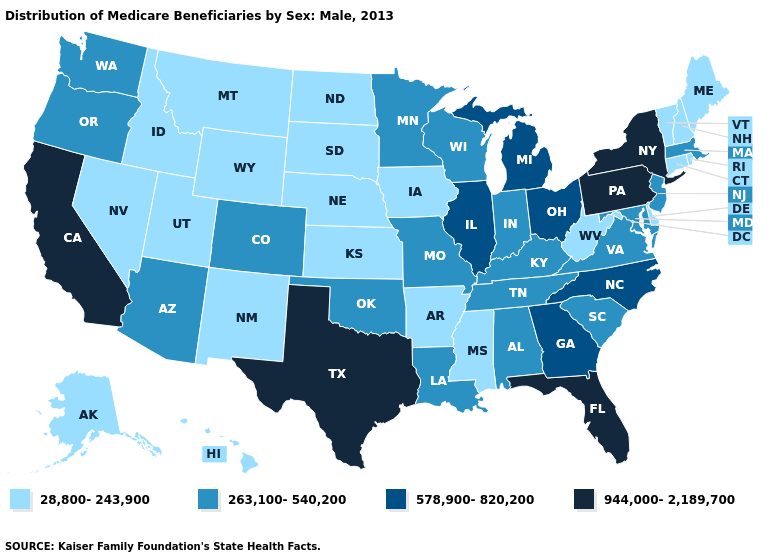What is the highest value in states that border Pennsylvania?
Concise answer only. 944,000-2,189,700. Among the states that border Missouri , which have the highest value?
Keep it brief. Illinois. Does the map have missing data?
Be succinct. No. Which states have the lowest value in the MidWest?
Keep it brief. Iowa, Kansas, Nebraska, North Dakota, South Dakota. What is the lowest value in the USA?
Give a very brief answer. 28,800-243,900. Name the states that have a value in the range 263,100-540,200?
Write a very short answer. Alabama, Arizona, Colorado, Indiana, Kentucky, Louisiana, Maryland, Massachusetts, Minnesota, Missouri, New Jersey, Oklahoma, Oregon, South Carolina, Tennessee, Virginia, Washington, Wisconsin. What is the value of Utah?
Write a very short answer. 28,800-243,900. Is the legend a continuous bar?
Be succinct. No. What is the value of North Carolina?
Be succinct. 578,900-820,200. Which states have the highest value in the USA?
Be succinct. California, Florida, New York, Pennsylvania, Texas. Which states have the highest value in the USA?
Quick response, please. California, Florida, New York, Pennsylvania, Texas. Which states hav the highest value in the MidWest?
Keep it brief. Illinois, Michigan, Ohio. What is the value of Massachusetts?
Answer briefly. 263,100-540,200. What is the value of Maryland?
Quick response, please. 263,100-540,200. What is the lowest value in the West?
Write a very short answer. 28,800-243,900. 